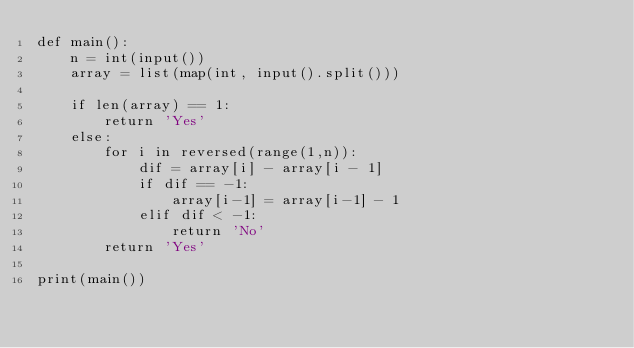<code> <loc_0><loc_0><loc_500><loc_500><_Python_>def main():
    n = int(input())
    array = list(map(int, input().split()))

    if len(array) == 1:
        return 'Yes'
    else:
        for i in reversed(range(1,n)):
            dif = array[i] - array[i - 1]
            if dif == -1:
                array[i-1] = array[i-1] - 1
            elif dif < -1:
                return 'No'
        return 'Yes'

print(main())</code> 